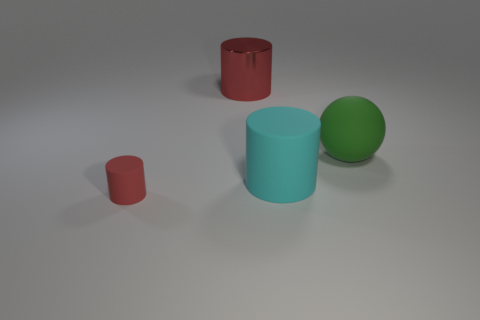Add 2 matte cylinders. How many objects exist? 6 Subtract all cyan cylinders. How many cylinders are left? 2 Subtract all balls. How many objects are left? 3 Subtract 3 cylinders. How many cylinders are left? 0 Subtract all cyan cylinders. How many cylinders are left? 2 Add 3 small red rubber objects. How many small red rubber objects are left? 4 Add 2 large blue metal cylinders. How many large blue metal cylinders exist? 2 Subtract 0 blue cubes. How many objects are left? 4 Subtract all brown cylinders. Subtract all blue cubes. How many cylinders are left? 3 Subtract all gray blocks. How many gray cylinders are left? 0 